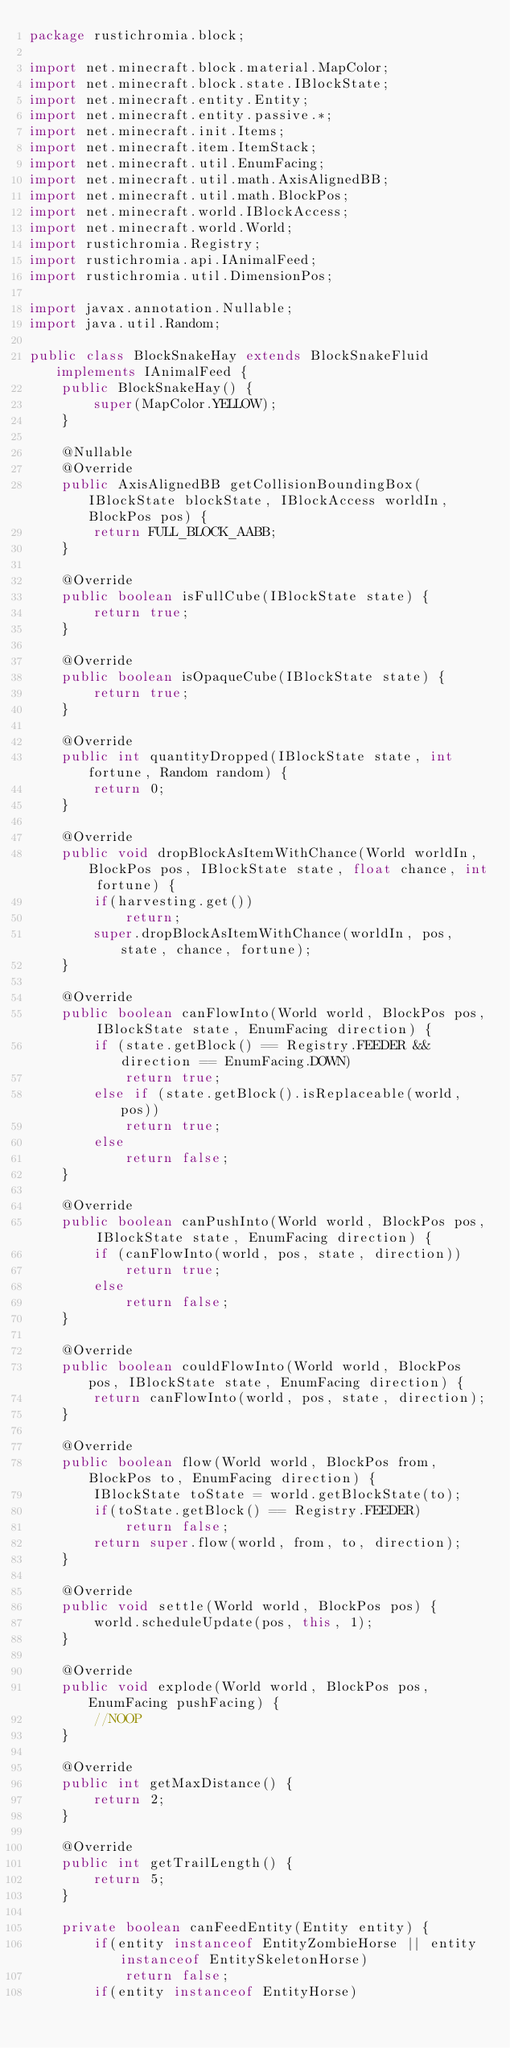<code> <loc_0><loc_0><loc_500><loc_500><_Java_>package rustichromia.block;

import net.minecraft.block.material.MapColor;
import net.minecraft.block.state.IBlockState;
import net.minecraft.entity.Entity;
import net.minecraft.entity.passive.*;
import net.minecraft.init.Items;
import net.minecraft.item.ItemStack;
import net.minecraft.util.EnumFacing;
import net.minecraft.util.math.AxisAlignedBB;
import net.minecraft.util.math.BlockPos;
import net.minecraft.world.IBlockAccess;
import net.minecraft.world.World;
import rustichromia.Registry;
import rustichromia.api.IAnimalFeed;
import rustichromia.util.DimensionPos;

import javax.annotation.Nullable;
import java.util.Random;

public class BlockSnakeHay extends BlockSnakeFluid implements IAnimalFeed {
    public BlockSnakeHay() {
        super(MapColor.YELLOW);
    }

    @Nullable
    @Override
    public AxisAlignedBB getCollisionBoundingBox(IBlockState blockState, IBlockAccess worldIn, BlockPos pos) {
        return FULL_BLOCK_AABB;
    }

    @Override
    public boolean isFullCube(IBlockState state) {
        return true;
    }

    @Override
    public boolean isOpaqueCube(IBlockState state) {
        return true;
    }

    @Override
    public int quantityDropped(IBlockState state, int fortune, Random random) {
        return 0;
    }

    @Override
    public void dropBlockAsItemWithChance(World worldIn, BlockPos pos, IBlockState state, float chance, int fortune) {
        if(harvesting.get())
            return;
        super.dropBlockAsItemWithChance(worldIn, pos, state, chance, fortune);
    }

    @Override
    public boolean canFlowInto(World world, BlockPos pos, IBlockState state, EnumFacing direction) {
        if (state.getBlock() == Registry.FEEDER && direction == EnumFacing.DOWN)
            return true;
        else if (state.getBlock().isReplaceable(world, pos))
            return true;
        else
            return false;
    }

    @Override
    public boolean canPushInto(World world, BlockPos pos, IBlockState state, EnumFacing direction) {
        if (canFlowInto(world, pos, state, direction))
            return true;
        else
            return false;
    }

    @Override
    public boolean couldFlowInto(World world, BlockPos pos, IBlockState state, EnumFacing direction) {
        return canFlowInto(world, pos, state, direction);
    }

    @Override
    public boolean flow(World world, BlockPos from, BlockPos to, EnumFacing direction) {
        IBlockState toState = world.getBlockState(to);
        if(toState.getBlock() == Registry.FEEDER)
            return false;
        return super.flow(world, from, to, direction);
    }

    @Override
    public void settle(World world, BlockPos pos) {
        world.scheduleUpdate(pos, this, 1);
    }

    @Override
    public void explode(World world, BlockPos pos, EnumFacing pushFacing) {
        //NOOP
    }

    @Override
    public int getMaxDistance() {
        return 2;
    }

    @Override
    public int getTrailLength() {
        return 5;
    }

    private boolean canFeedEntity(Entity entity) {
        if(entity instanceof EntityZombieHorse || entity instanceof EntitySkeletonHorse)
            return false;
        if(entity instanceof EntityHorse)</code> 